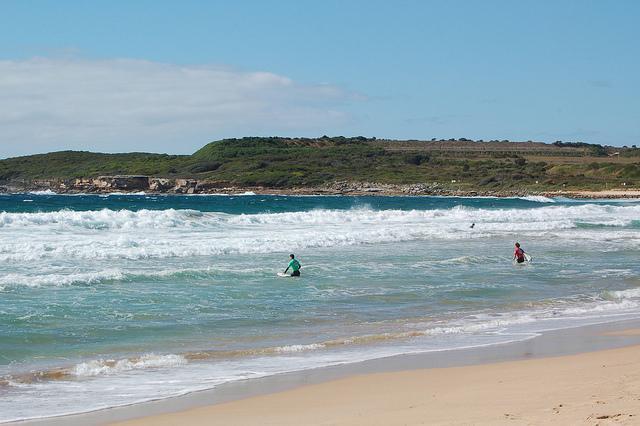How many people are in the water?
Give a very brief answer. 2. 